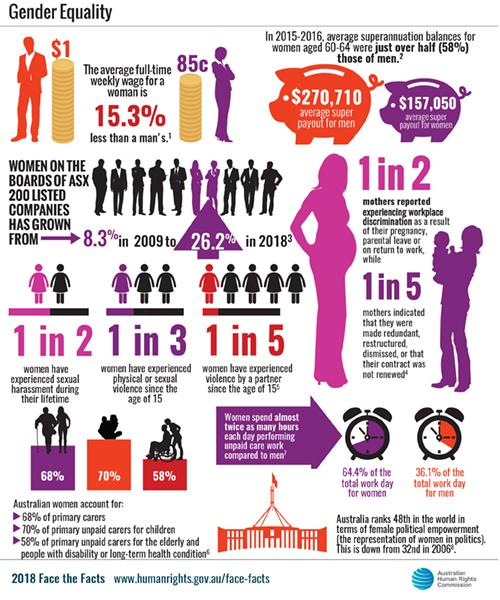Draw attention to some important aspects in this diagram. According to research, only 1 in 3 women have not faced any form of harassment since the age of 15. According to recent statistics, 58% of Australian women serve as the primary caretakers of senior citizens. The difference in weekly wages between males and females is 15.3%. From 2009 to 2018, the percentage of women on the boards of ASX-listed companies increased by 17.9%. Research has shown that approximately 50% of mothers did not experience any discrimination. 